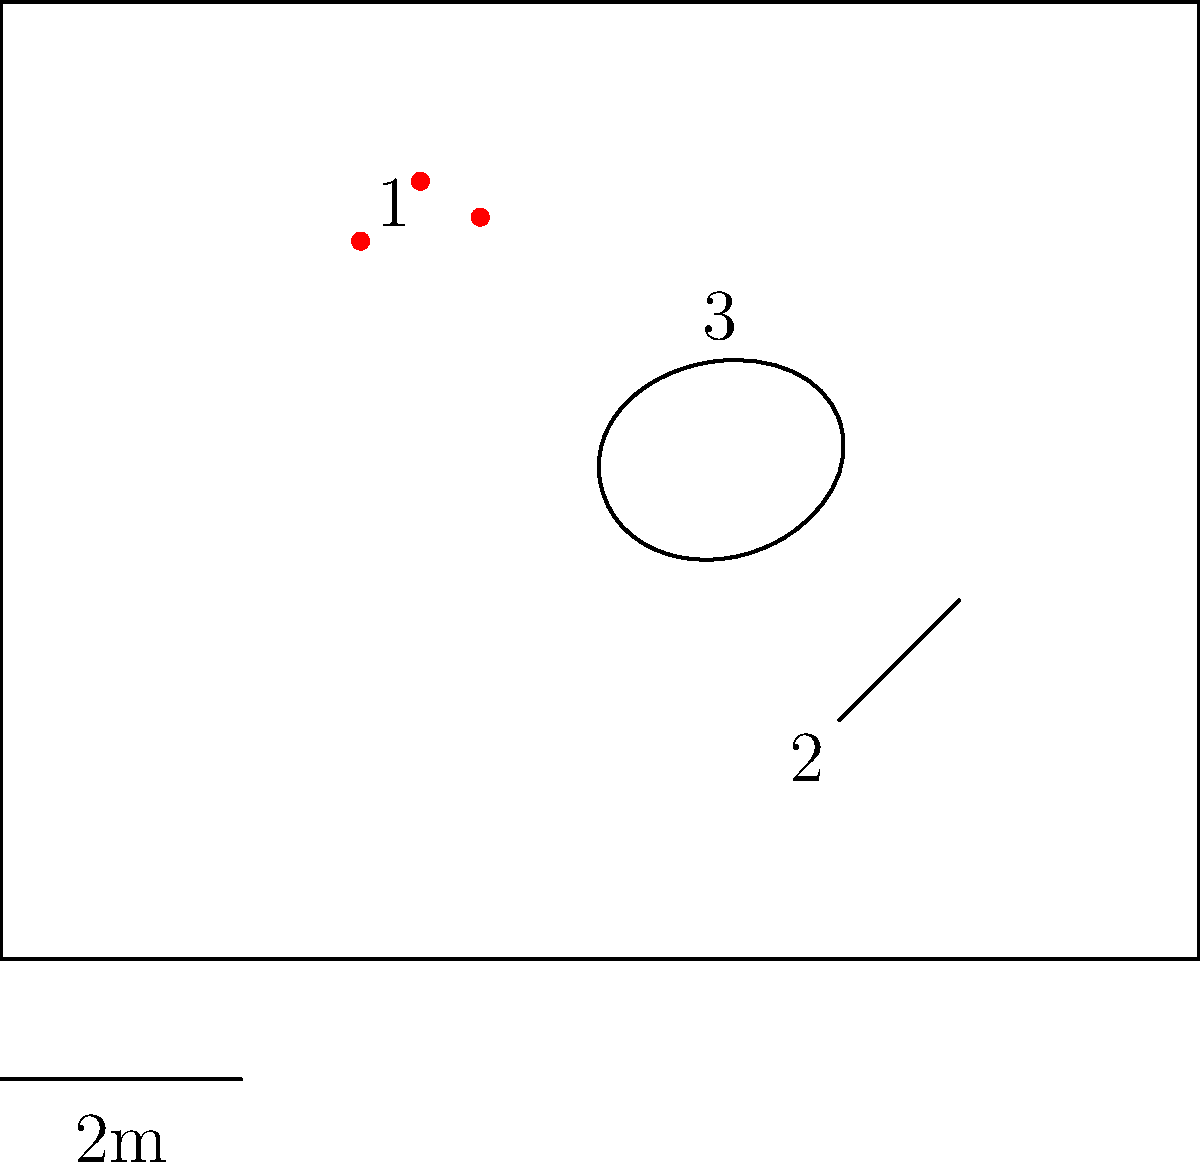Based on the crime scene layout provided, which piece of evidence is most likely to provide crucial information about the perpetrator's entry point? To determine the most crucial evidence for identifying the perpetrator's entry point, let's analyze the crime scene layout step-by-step:

1. Observe the room layout:
   - The room has one door on the left side and one window on the right side.
   - These are the two potential entry points for the perpetrator.

2. Examine the evidence markers:
   - Marker 1: Blood spatter near the top left corner
   - Marker 2: Potential weapon in the bottom right area
   - Marker 3: Body outline in the center of the room

3. Analyze the blood spatter (Marker 1):
   - Located close to the door
   - Suggests a possible struggle or impact near the entrance

4. Consider the weapon's position (Marker 2):
   - Far from both the door and window
   - Less likely to indicate the entry point

5. Evaluate the body's position (Marker 3):
   - Central location
   - Doesn't directly suggest the entry point

6. Compare the evidence in relation to entry points:
   - The blood spatter is closest to the door
   - No significant evidence is near the window

Conclusion: The blood spatter (Marker 1) is most likely to provide crucial information about the perpetrator's entry point. Its proximity to the door suggests that the perpetrator may have entered through the door, potentially engaging in a struggle with the victim upon entry.
Answer: Blood spatter (Marker 1) 